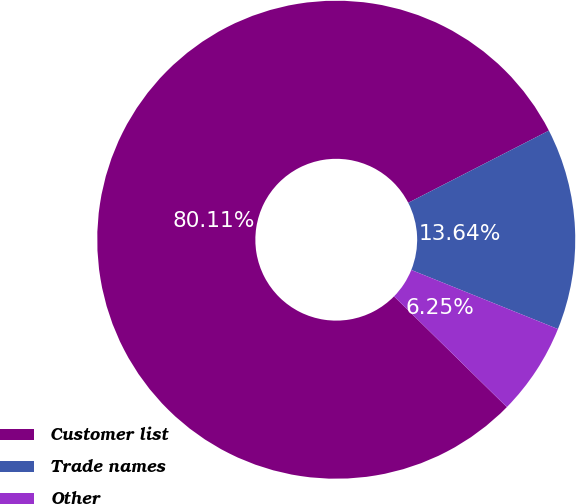Convert chart to OTSL. <chart><loc_0><loc_0><loc_500><loc_500><pie_chart><fcel>Customer list<fcel>Trade names<fcel>Other<nl><fcel>80.11%<fcel>13.64%<fcel>6.25%<nl></chart> 